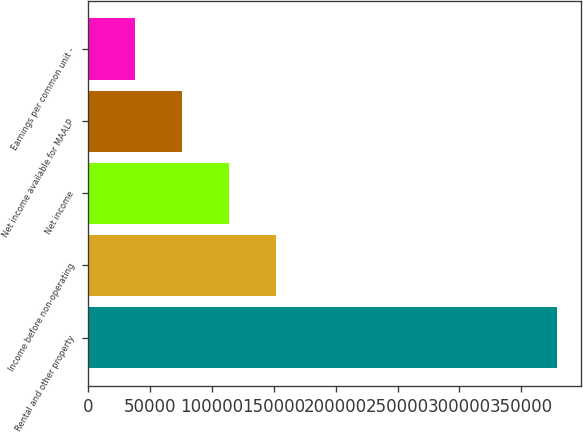Convert chart. <chart><loc_0><loc_0><loc_500><loc_500><bar_chart><fcel>Rental and other property<fcel>Income before non-operating<fcel>Net income<fcel>Net income available for MAALP<fcel>Earnings per common unit -<nl><fcel>378908<fcel>151563<fcel>113673<fcel>75781.9<fcel>37891.1<nl></chart> 